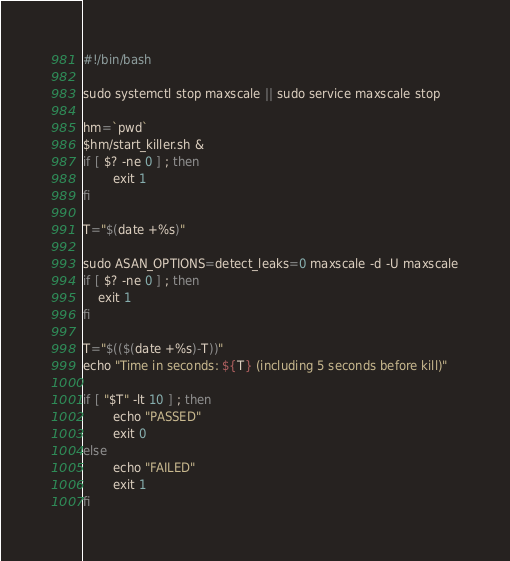Convert code to text. <code><loc_0><loc_0><loc_500><loc_500><_Bash_>#!/bin/bash

sudo systemctl stop maxscale || sudo service maxscale stop

hm=`pwd`
$hm/start_killer.sh &
if [ $? -ne 0 ] ; then
        exit 1
fi

T="$(date +%s)"

sudo ASAN_OPTIONS=detect_leaks=0 maxscale -d -U maxscale
if [ $? -ne 0 ] ; then
	exit 1
fi

T="$(($(date +%s)-T))"
echo "Time in seconds: ${T} (including 5 seconds before kill)"

if [ "$T" -lt 10 ] ; then
        echo "PASSED"
        exit 0
else
        echo "FAILED"
        exit 1
fi

</code> 